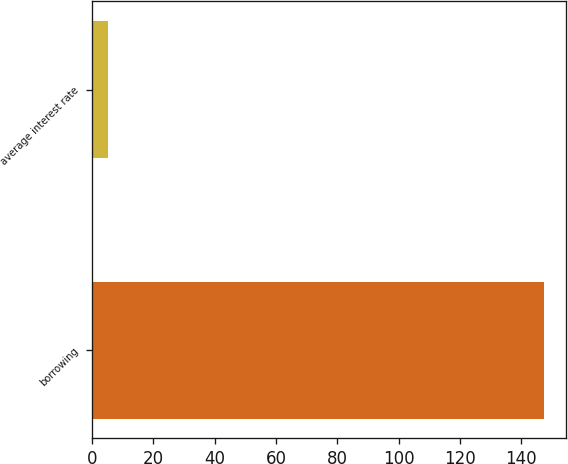<chart> <loc_0><loc_0><loc_500><loc_500><bar_chart><fcel>borrowing<fcel>average interest rate<nl><fcel>147.3<fcel>5.3<nl></chart> 